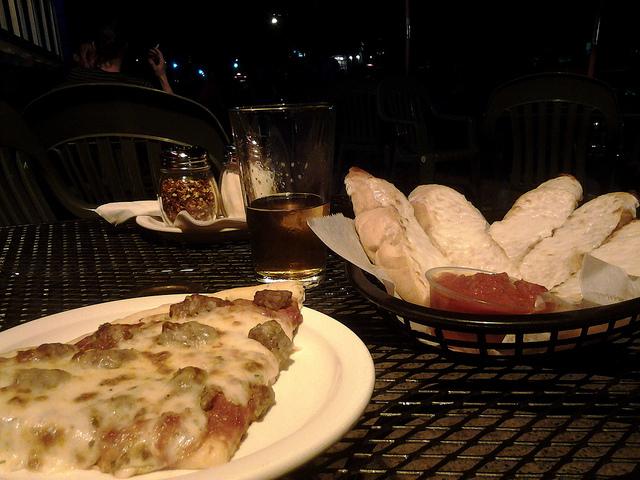What kind of pepper is on the table?
Be succinct. Red pepper. Is the glass half full or half empty?
Concise answer only. Half empty. What time of day is it?
Write a very short answer. Night. How many slices of Pizza are on the table?
Be succinct. 1. 